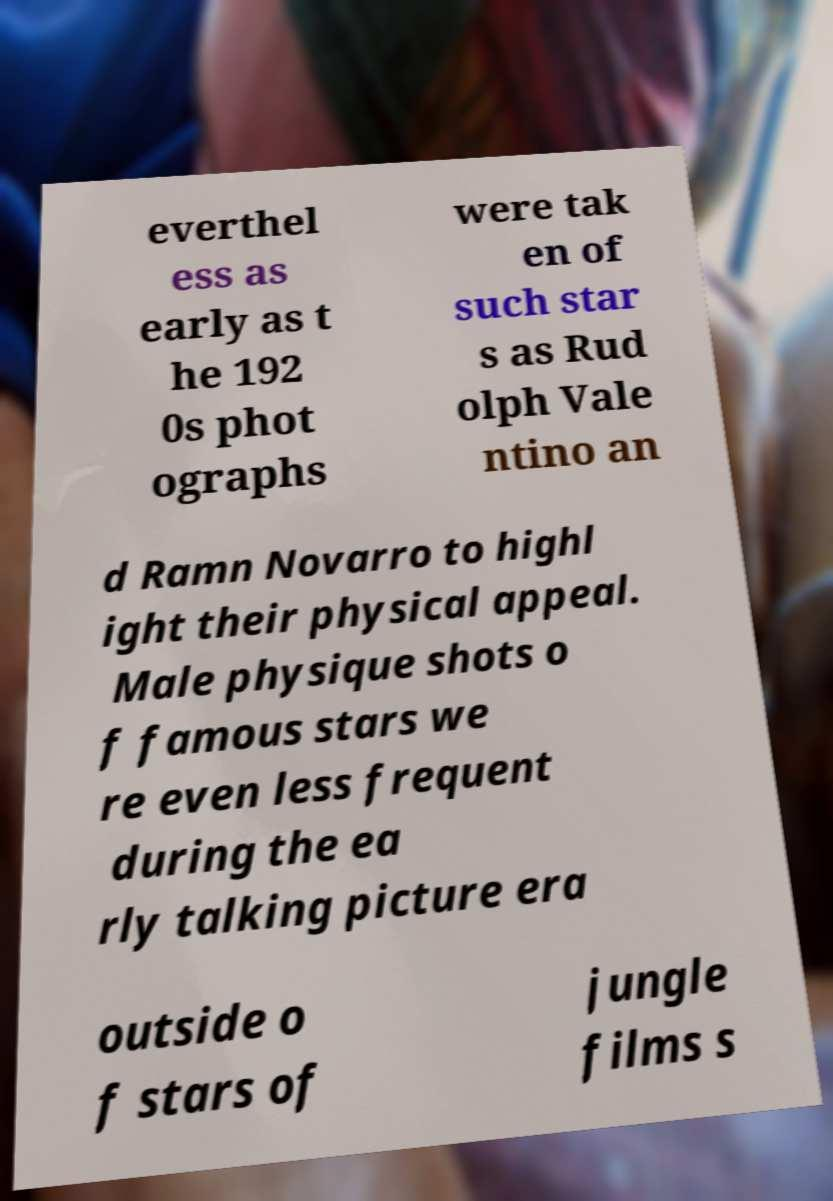Could you assist in decoding the text presented in this image and type it out clearly? everthel ess as early as t he 192 0s phot ographs were tak en of such star s as Rud olph Vale ntino an d Ramn Novarro to highl ight their physical appeal. Male physique shots o f famous stars we re even less frequent during the ea rly talking picture era outside o f stars of jungle films s 